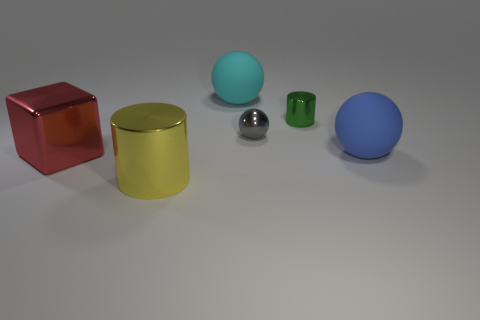How many other things are there of the same size as the cyan matte thing?
Offer a terse response. 3. Does the shiny cube have the same color as the large shiny cylinder?
Offer a very short reply. No. There is a gray metal thing that is right of the metallic cylinder left of the large ball left of the big blue sphere; what shape is it?
Provide a short and direct response. Sphere. How many things are large spheres that are behind the blue ball or things that are in front of the blue rubber ball?
Provide a succinct answer. 3. There is a rubber ball that is to the right of the rubber ball that is behind the big blue matte thing; what is its size?
Make the answer very short. Large. There is a big sphere that is left of the tiny cylinder; does it have the same color as the big cylinder?
Make the answer very short. No. Is there another tiny object of the same shape as the cyan thing?
Offer a very short reply. Yes. There is a cylinder that is the same size as the red shiny thing; what color is it?
Ensure brevity in your answer.  Yellow. How big is the matte sphere in front of the green object?
Your answer should be very brief. Large. Is there a tiny gray shiny object left of the big thing that is on the left side of the large yellow cylinder?
Provide a succinct answer. No. 